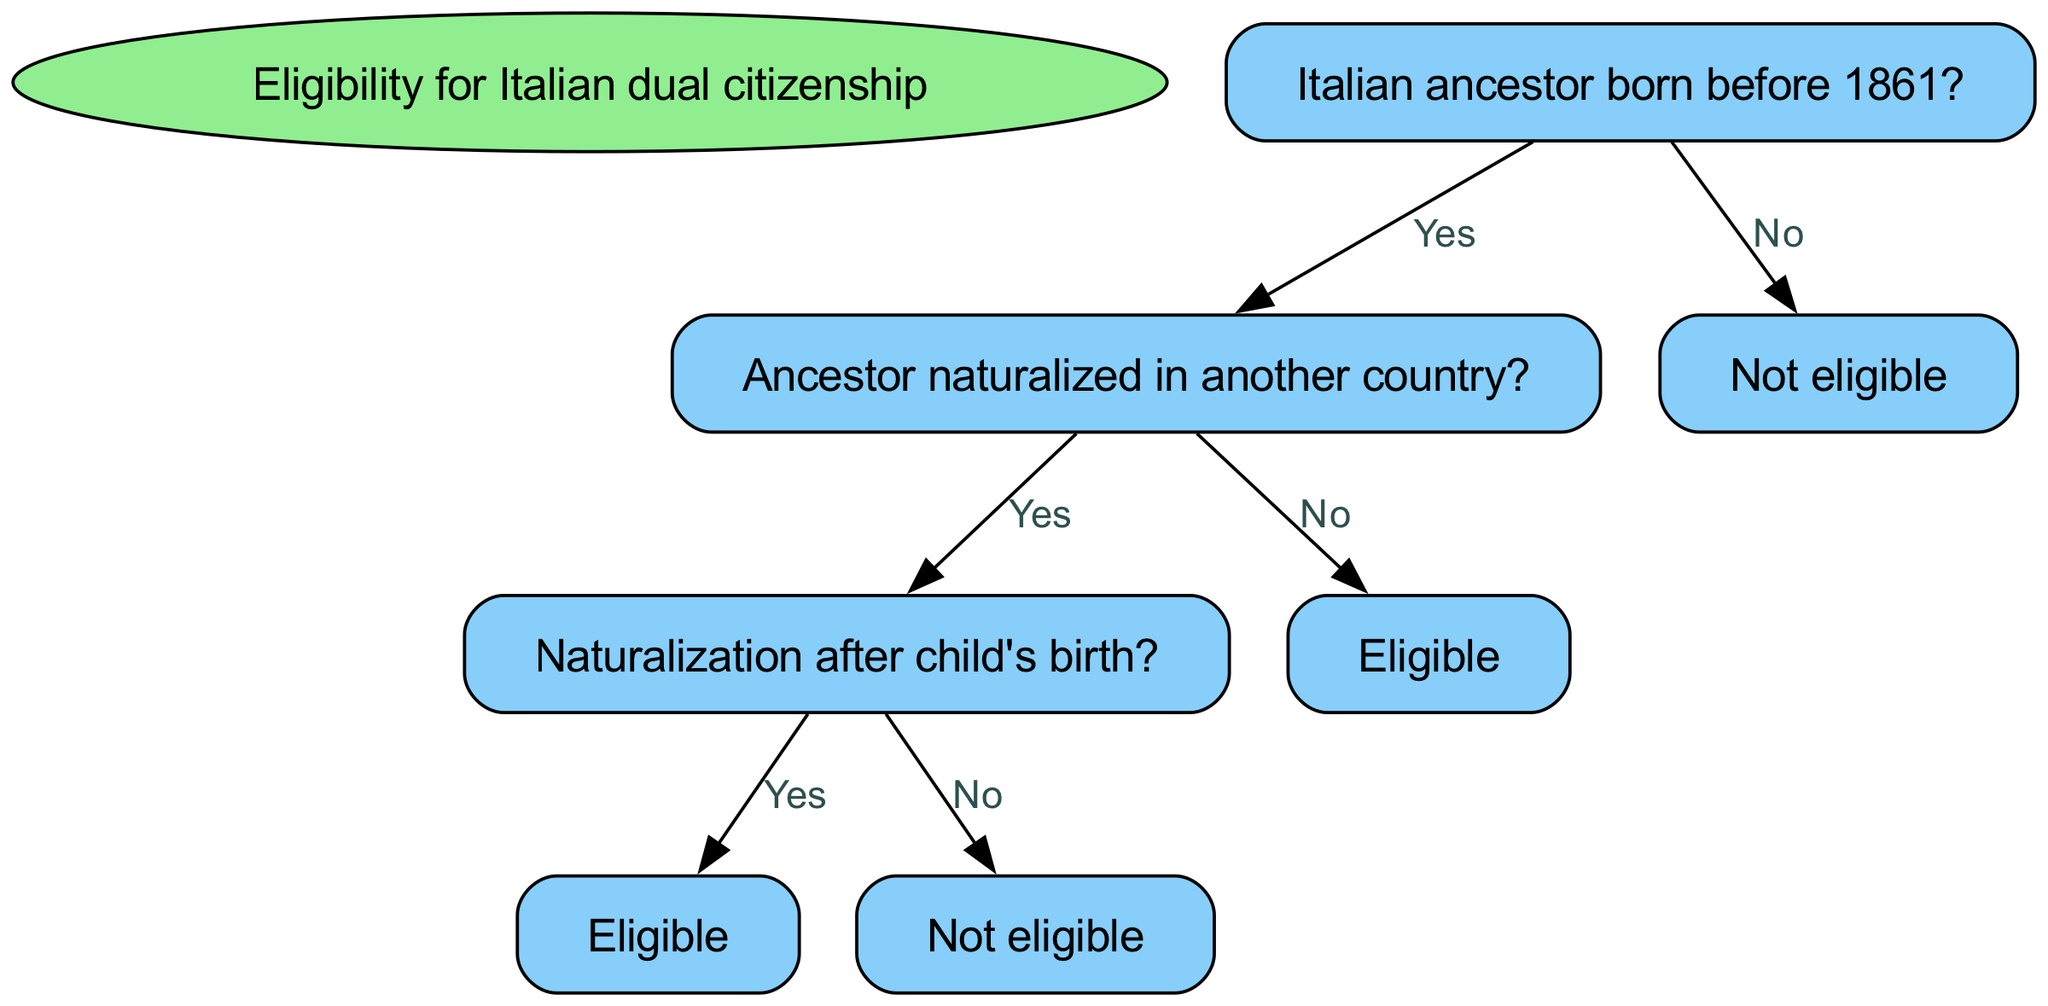What is the main decision point in the diagram? The main decision point in the diagram is the question regarding whether the Italian ancestor was born before 1861. This serves as the root of the decision tree from which all other decisions branch out.
Answer: Italian ancestor born before 1861? If the answer is "No" to the main decision point, what is the resulting outcome? If the answer to the main decision point (about the ancestor's birth year) is "No," it leads directly to a terminal node that states "Not eligible," indicating that the applicant cannot qualify for dual citizenship under these circumstances.
Answer: Not eligible How many nodes are there in the decision tree? The decision tree contains a total of seven nodes: one root node, five decision nodes, and one terminal node. Each node represents a question or outcome related to eligibility for Italian dual citizenship.
Answer: Seven If the ancestor was naturalized in another country, what is the next question? If the ancestor was naturalized in another country (answering "Yes" to the second question), the next question asked relates to whether the naturalization occurred after the child's birth. This continues the process of assessing eligibility based on the ancestor's citizenship status.
Answer: Naturalization after child's birth? What is the outcome if the ancestor's naturalization occurred after the child's birth? If the ancestor's naturalization occurred after the child's birth (answering "Yes" to that question), the outcome is "Eligible," meaning the applicant can qualify for Italian dual citizenship due to the circumstances of the ancestor's naturalization timing.
Answer: Eligible Is there any scenario where the applicant is eligible without the ancestor being naturalized? Yes, as long as the ancestor was born before 1861 and did not naturalize in a different country, the applicant would still be eligible for Italian dual citizenship, indicating that the ancestor's birth year is critical for eligibility.
Answer: Yes 